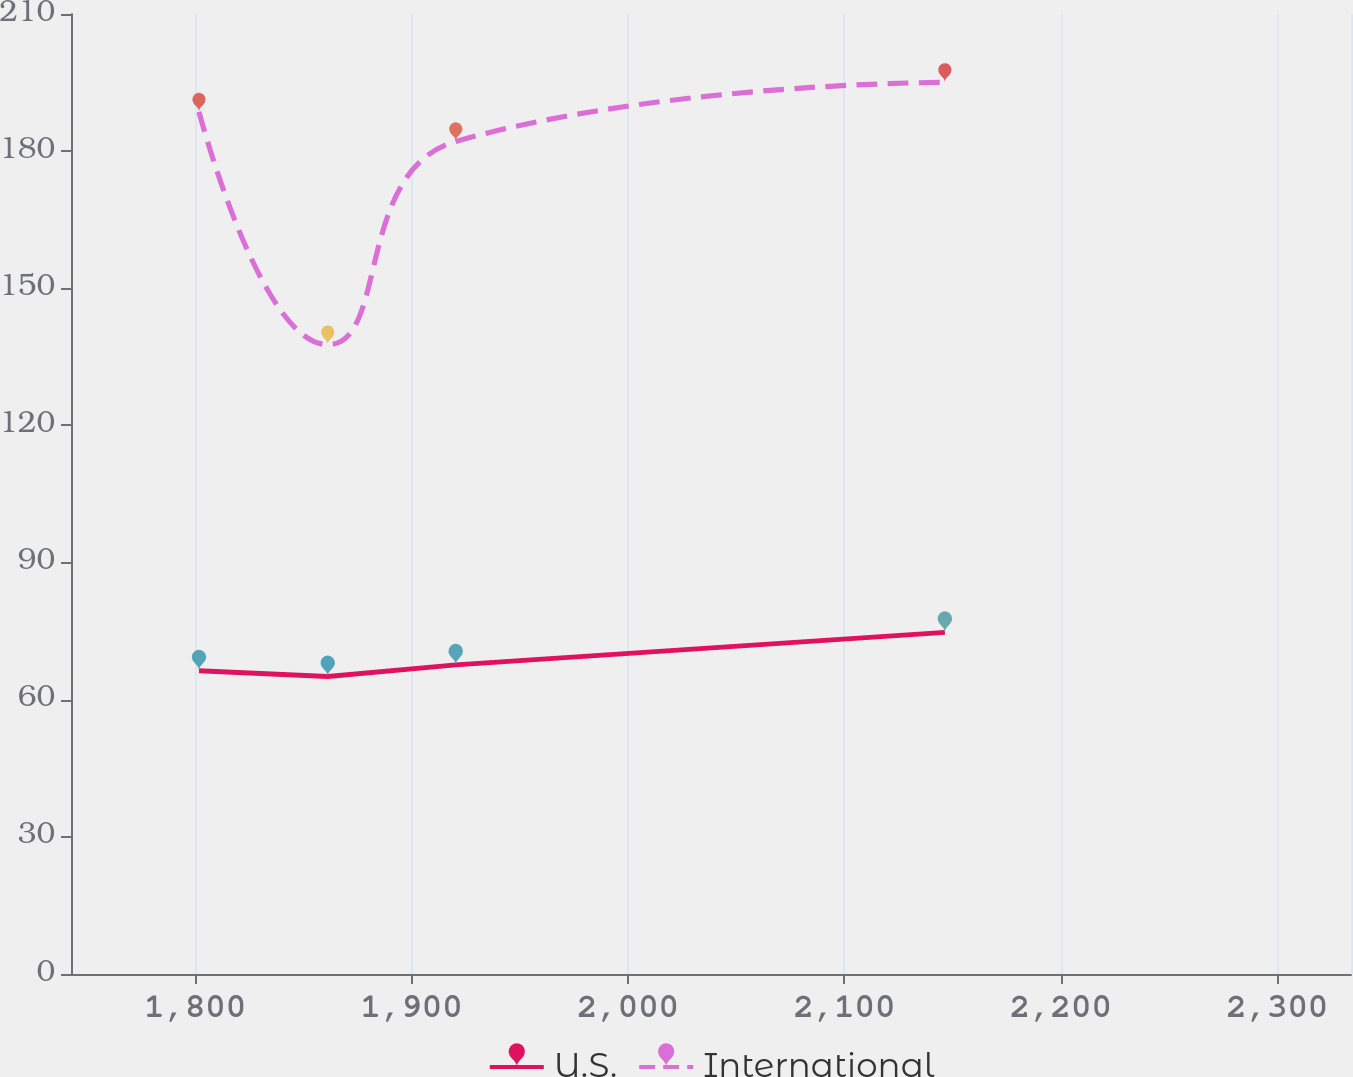Convert chart. <chart><loc_0><loc_0><loc_500><loc_500><line_chart><ecel><fcel>U.S.<fcel>International<nl><fcel>1801.78<fcel>66.34<fcel>188.58<nl><fcel>1861.27<fcel>65.08<fcel>137.67<nl><fcel>1920.42<fcel>67.64<fcel>182.12<nl><fcel>2146.44<fcel>74.75<fcel>195.04<nl><fcel>2393.25<fcel>72.49<fcel>202.23<nl></chart> 